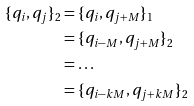Convert formula to latex. <formula><loc_0><loc_0><loc_500><loc_500>\{ q _ { i } , q _ { j } \} _ { 2 } & = \{ q _ { i } , q _ { j + M } \} _ { 1 } \\ & = \{ q _ { i - M } , q _ { j + M } \} _ { 2 } \\ & = \dots \\ & = \{ q _ { i - k M } , q _ { j + k M } \} _ { 2 } \\</formula> 